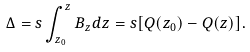<formula> <loc_0><loc_0><loc_500><loc_500>\Delta = s \int ^ { z } _ { z _ { 0 } } B _ { z } d z = s [ Q ( z _ { 0 } ) - Q ( z ) ] .</formula> 